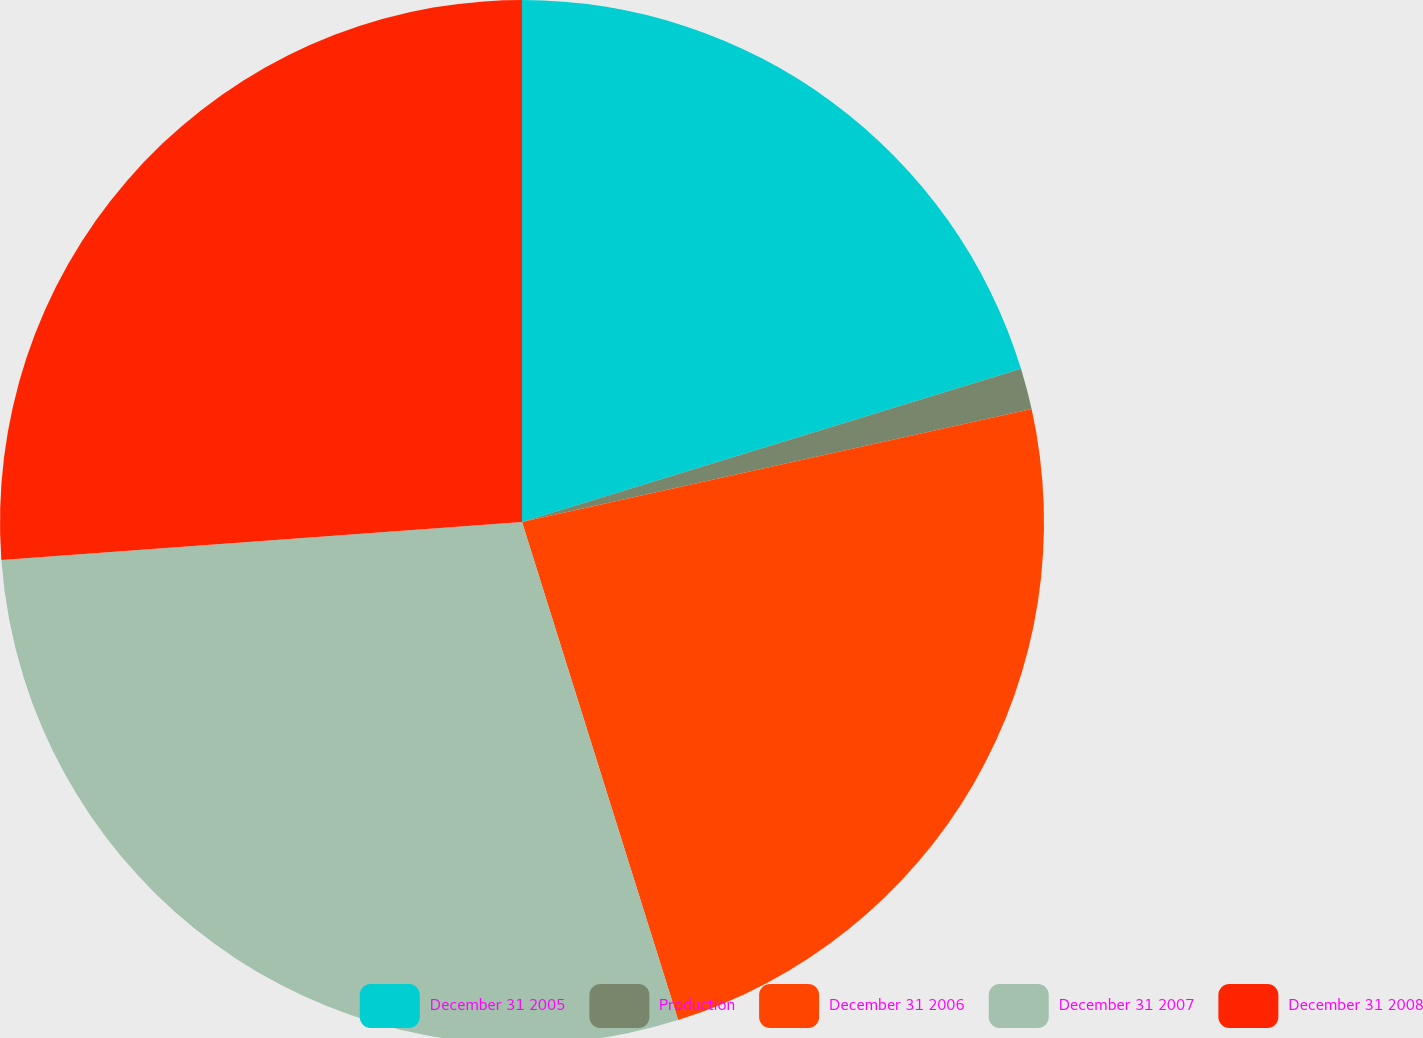Convert chart. <chart><loc_0><loc_0><loc_500><loc_500><pie_chart><fcel>December 31 2005<fcel>Production<fcel>December 31 2006<fcel>December 31 2007<fcel>December 31 2008<nl><fcel>20.26%<fcel>1.27%<fcel>23.64%<fcel>28.68%<fcel>26.16%<nl></chart> 